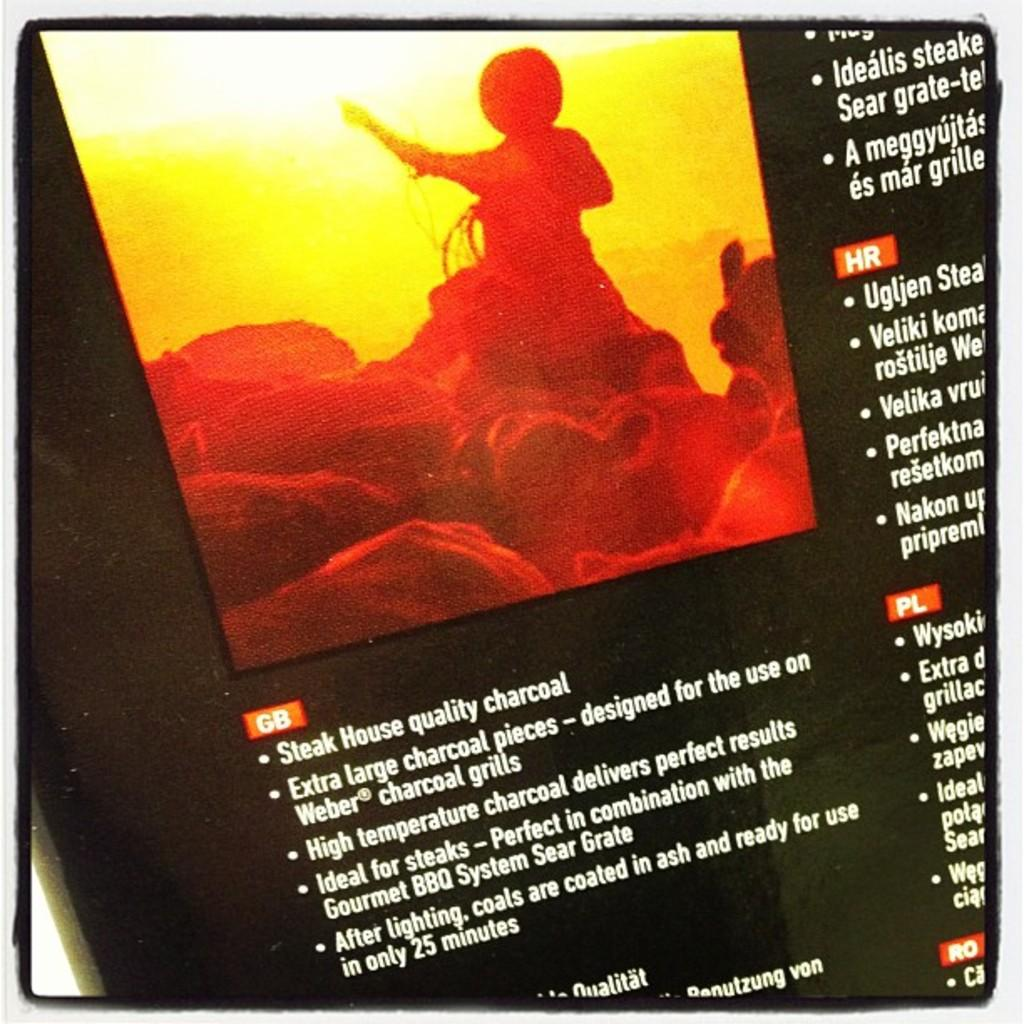<image>
Create a compact narrative representing the image presented. A cowboy and some animals with the writing steak house quality charcoal as well as other text. 